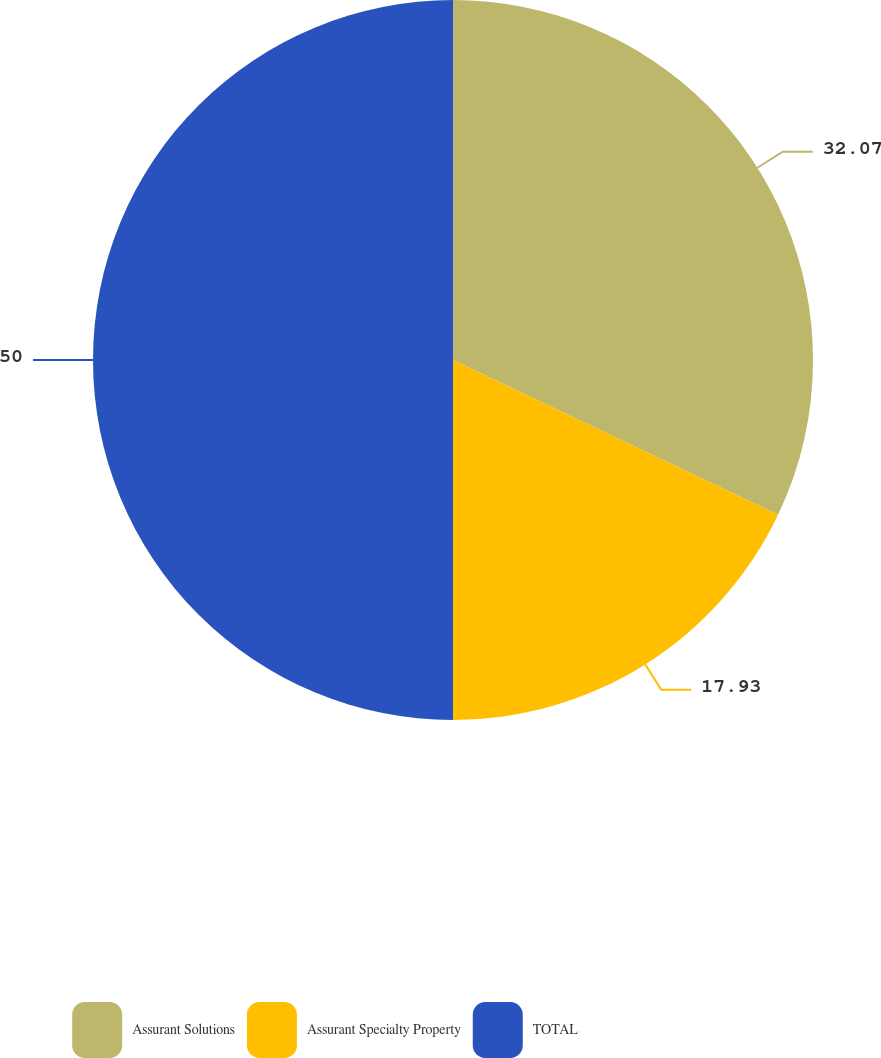Convert chart. <chart><loc_0><loc_0><loc_500><loc_500><pie_chart><fcel>Assurant Solutions<fcel>Assurant Specialty Property<fcel>TOTAL<nl><fcel>32.07%<fcel>17.93%<fcel>50.0%<nl></chart> 